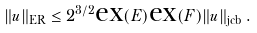Convert formula to latex. <formula><loc_0><loc_0><loc_500><loc_500>\| u \| _ { \text {ER} } \leq 2 ^ { 3 / 2 } \text {ex} ( E ) \text {ex} ( F ) \| u \| _ { \text {jcb} } \, .</formula> 